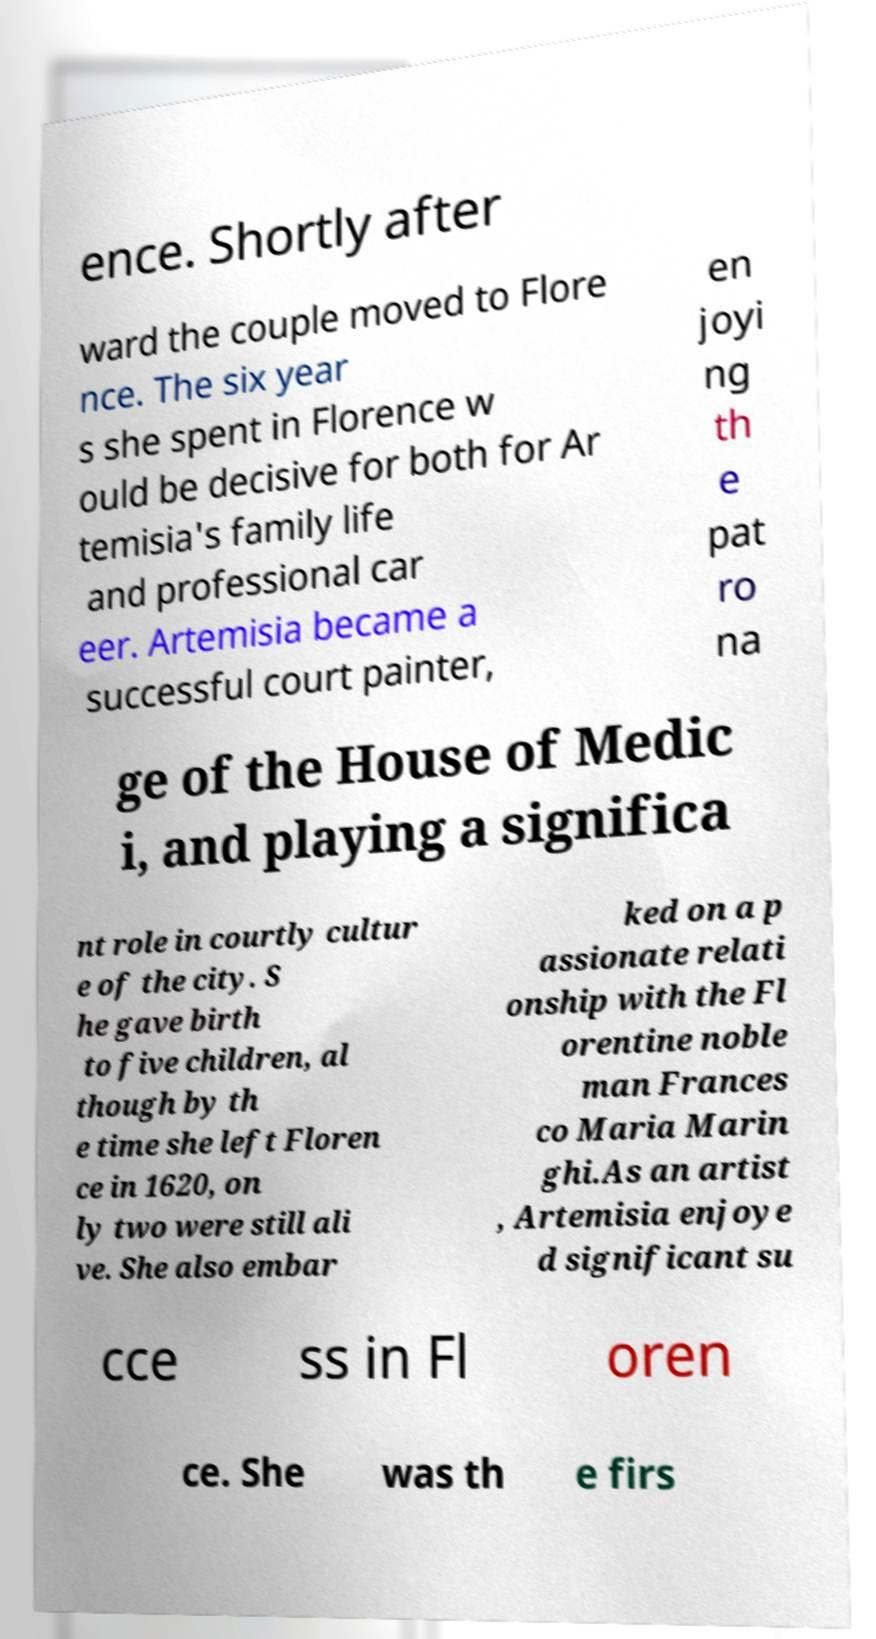Please read and relay the text visible in this image. What does it say? ence. Shortly after ward the couple moved to Flore nce. The six year s she spent in Florence w ould be decisive for both for Ar temisia's family life and professional car eer. Artemisia became a successful court painter, en joyi ng th e pat ro na ge of the House of Medic i, and playing a significa nt role in courtly cultur e of the city. S he gave birth to five children, al though by th e time she left Floren ce in 1620, on ly two were still ali ve. She also embar ked on a p assionate relati onship with the Fl orentine noble man Frances co Maria Marin ghi.As an artist , Artemisia enjoye d significant su cce ss in Fl oren ce. She was th e firs 